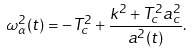Convert formula to latex. <formula><loc_0><loc_0><loc_500><loc_500>\omega _ { \alpha } ^ { 2 } ( t ) = - T _ { c } ^ { 2 } + \frac { k ^ { 2 } + T _ { c } ^ { 2 } a _ { c } ^ { 2 } } { a ^ { 2 } ( t ) } .</formula> 